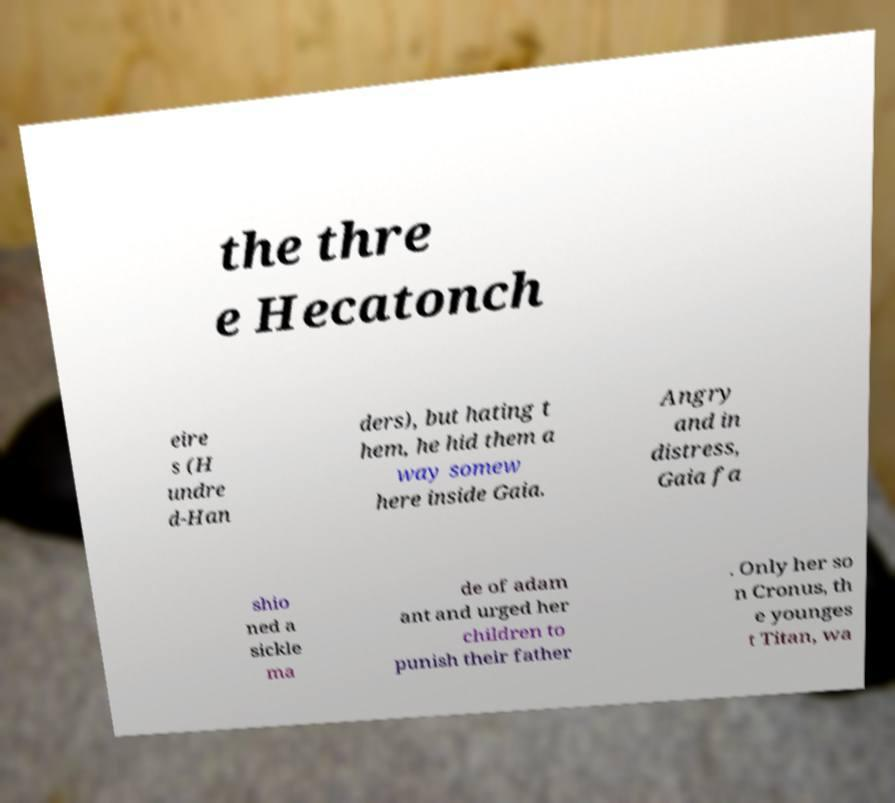There's text embedded in this image that I need extracted. Can you transcribe it verbatim? the thre e Hecatonch eire s (H undre d-Han ders), but hating t hem, he hid them a way somew here inside Gaia. Angry and in distress, Gaia fa shio ned a sickle ma de of adam ant and urged her children to punish their father . Only her so n Cronus, th e younges t Titan, wa 